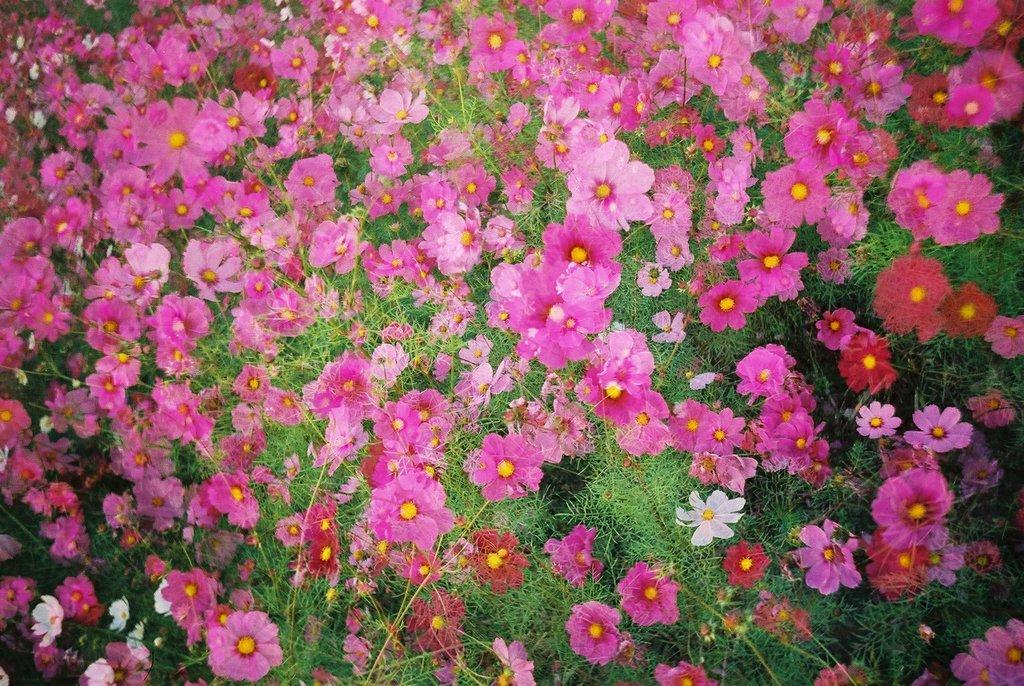What type of flowers can be seen in the image? There are many pink flowers in the image. Can you describe the color of the flowers? The flowers are pink. How many flowers are visible in the image? The image shows many pink flowers. What type of polish is being applied to the flowers in the image? There is no polish being applied to the flowers in the image; they are simply pink flowers. How does the guide help the flowers in the image? There is no guide present in the image, as it only features pink flowers. 